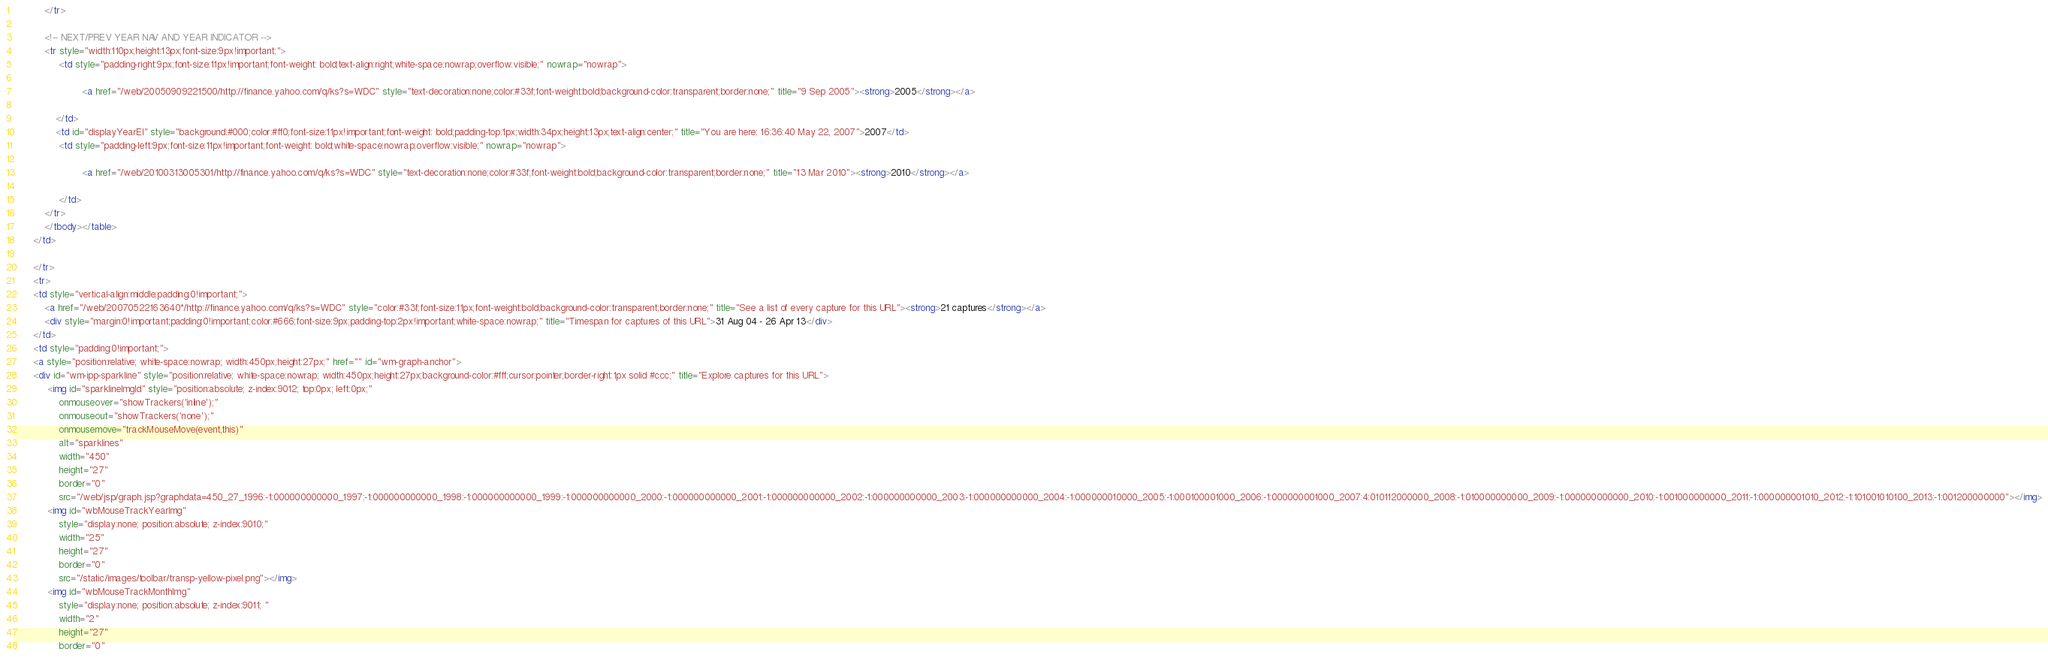<code> <loc_0><loc_0><loc_500><loc_500><_HTML_>           </tr>

           <!-- NEXT/PREV YEAR NAV AND YEAR INDICATOR -->
           <tr style="width:110px;height:13px;font-size:9px!important;">
				<td style="padding-right:9px;font-size:11px!important;font-weight: bold;text-align:right;white-space:nowrap;overflow:visible;" nowrap="nowrap">
               
		                <a href="/web/20050909221500/http://finance.yahoo.com/q/ks?s=WDC" style="text-decoration:none;color:#33f;font-weight:bold;background-color:transparent;border:none;" title="9 Sep 2005"><strong>2005</strong></a>
		                
               </td>
               <td id="displayYearEl" style="background:#000;color:#ff0;font-size:11px!important;font-weight: bold;padding-top:1px;width:34px;height:13px;text-align:center;" title="You are here: 16:36:40 May 22, 2007">2007</td>
				<td style="padding-left:9px;font-size:11px!important;font-weight: bold;white-space:nowrap;overflow:visible;" nowrap="nowrap">
               
		                <a href="/web/20100313005301/http://finance.yahoo.com/q/ks?s=WDC" style="text-decoration:none;color:#33f;font-weight:bold;background-color:transparent;border:none;" title="13 Mar 2010"><strong>2010</strong></a>
		                
				</td>
           </tr>
           </tbody></table>
       </td>

       </tr>
       <tr>
       <td style="vertical-align:middle;padding:0!important;">
           <a href="/web/20070522163640*/http://finance.yahoo.com/q/ks?s=WDC" style="color:#33f;font-size:11px;font-weight:bold;background-color:transparent;border:none;" title="See a list of every capture for this URL"><strong>21 captures</strong></a>
           <div style="margin:0!important;padding:0!important;color:#666;font-size:9px;padding-top:2px!important;white-space:nowrap;" title="Timespan for captures of this URL">31 Aug 04 - 26 Apr 13</div>
       </td>
       <td style="padding:0!important;">
       <a style="position:relative; white-space:nowrap; width:450px;height:27px;" href="" id="wm-graph-anchor">
       <div id="wm-ipp-sparkline" style="position:relative; white-space:nowrap; width:450px;height:27px;background-color:#fff;cursor:pointer;border-right:1px solid #ccc;" title="Explore captures for this URL">
			<img id="sparklineImgId" style="position:absolute; z-index:9012; top:0px; left:0px;"
				onmouseover="showTrackers('inline');" 
				onmouseout="showTrackers('none');"
				onmousemove="trackMouseMove(event,this)"
				alt="sparklines"
				width="450"
				height="27"
				border="0"
				src="/web/jsp/graph.jsp?graphdata=450_27_1996:-1:000000000000_1997:-1:000000000000_1998:-1:000000000000_1999:-1:000000000000_2000:-1:000000000000_2001:-1:000000000000_2002:-1:000000000000_2003:-1:000000000000_2004:-1:000000010000_2005:-1:000100001000_2006:-1:000000001000_2007:4:010112000000_2008:-1:010000000000_2009:-1:000000000000_2010:-1:001000000000_2011:-1:000000001010_2012:-1:101001010100_2013:-1:001200000000"></img>
			<img id="wbMouseTrackYearImg" 
				style="display:none; position:absolute; z-index:9010;"
				width="25" 
				height="27"
				border="0"
				src="/static/images/toolbar/transp-yellow-pixel.png"></img>
			<img id="wbMouseTrackMonthImg"
				style="display:none; position:absolute; z-index:9011; " 
				width="2"
				height="27" 
				border="0"</code> 